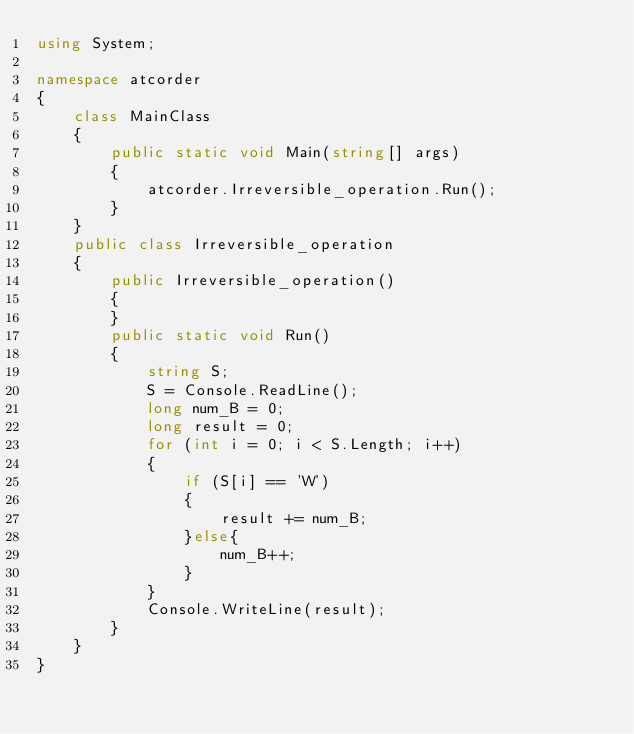Convert code to text. <code><loc_0><loc_0><loc_500><loc_500><_C#_>using System;

namespace atcorder
{
    class MainClass
    {
        public static void Main(string[] args)
        {
            atcorder.Irreversible_operation.Run();
        }
    }
    public class Irreversible_operation
    {
        public Irreversible_operation()
        {
        }
        public static void Run()
        {
            string S;
            S = Console.ReadLine();
            long num_B = 0;
            long result = 0;
            for (int i = 0; i < S.Length; i++)
            {
                if (S[i] == 'W')
                {
                    result += num_B;
                }else{
                    num_B++;
                }
            }
            Console.WriteLine(result);
        }
    }
}
</code> 